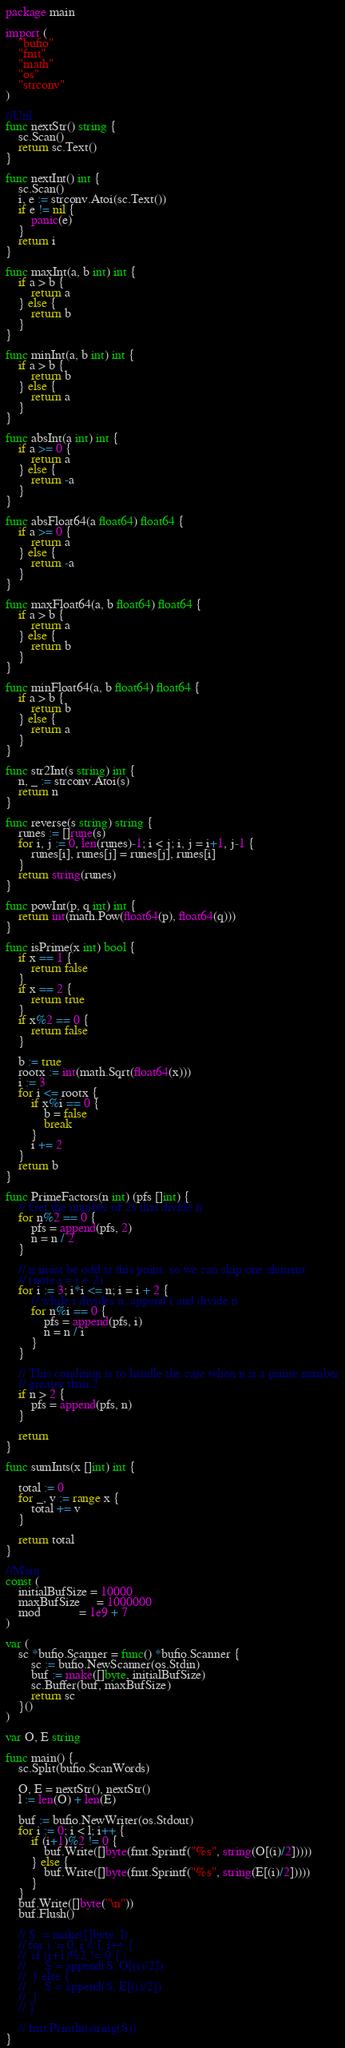<code> <loc_0><loc_0><loc_500><loc_500><_Go_>package main

import (
	"bufio"
	"fmt"
	"math"
	"os"
	"strconv"
)

//Util
func nextStr() string {
	sc.Scan()
	return sc.Text()
}

func nextInt() int {
	sc.Scan()
	i, e := strconv.Atoi(sc.Text())
	if e != nil {
		panic(e)
	}
	return i
}

func maxInt(a, b int) int {
	if a > b {
		return a
	} else {
		return b
	}
}

func minInt(a, b int) int {
	if a > b {
		return b
	} else {
		return a
	}
}

func absInt(a int) int {
	if a >= 0 {
		return a
	} else {
		return -a
	}
}

func absFloat64(a float64) float64 {
	if a >= 0 {
		return a
	} else {
		return -a
	}
}

func maxFloat64(a, b float64) float64 {
	if a > b {
		return a
	} else {
		return b
	}
}

func minFloat64(a, b float64) float64 {
	if a > b {
		return b
	} else {
		return a
	}
}

func str2Int(s string) int {
	n, _ := strconv.Atoi(s)
	return n
}

func reverse(s string) string {
	runes := []rune(s)
	for i, j := 0, len(runes)-1; i < j; i, j = i+1, j-1 {
		runes[i], runes[j] = runes[j], runes[i]
	}
	return string(runes)
}

func powInt(p, q int) int {
	return int(math.Pow(float64(p), float64(q)))
}

func isPrime(x int) bool {
	if x == 1 {
		return false
	}
	if x == 2 {
		return true
	}
	if x%2 == 0 {
		return false
	}

	b := true
	rootx := int(math.Sqrt(float64(x)))
	i := 3
	for i <= rootx {
		if x%i == 0 {
			b = false
			break
		}
		i += 2
	}
	return b
}

func PrimeFactors(n int) (pfs []int) {
	// Get the number of 2s that divide n
	for n%2 == 0 {
		pfs = append(pfs, 2)
		n = n / 2
	}

	// n must be odd at this point. so we can skip one element
	// (note i = i + 2)
	for i := 3; i*i <= n; i = i + 2 {
		// while i divides n, append i and divide n
		for n%i == 0 {
			pfs = append(pfs, i)
			n = n / i
		}
	}

	// This condition is to handle the case when n is a prime number
	// greater than 2
	if n > 2 {
		pfs = append(pfs, n)
	}

	return
}

func sumInts(x []int) int {

	total := 0
	for _, v := range x {
		total += v
	}

	return total
}

//Main
const (
	initialBufSize = 10000
	maxBufSize     = 1000000
	mod            = 1e9 + 7
)

var (
	sc *bufio.Scanner = func() *bufio.Scanner {
		sc := bufio.NewScanner(os.Stdin)
		buf := make([]byte, initialBufSize)
		sc.Buffer(buf, maxBufSize)
		return sc
	}()
)

var O, E string

func main() {
	sc.Split(bufio.ScanWords)

	O, E = nextStr(), nextStr()
	l := len(O) + len(E)

	buf := bufio.NewWriter(os.Stdout)
	for i := 0; i < l; i++ {
		if (i+1)%2 != 0 {
			buf.Write([]byte(fmt.Sprintf("%s", string(O[(i)/2]))))
		} else {
			buf.Write([]byte(fmt.Sprintf("%s", string(E[(i)/2]))))
		}
	}
	buf.Write([]byte("\n"))
	buf.Flush()

	// S := make([]byte, l)
	// for i := 0; i < l; i++ {
	// 	if (i+1)%2 != 0 {
	// 		S = append(S, O[(i)/2])
	// 	} else {
	// 		S = append(S, E[(i)/2])
	// 	}
	// }

	// fmt.Println(string(S))
}
</code> 